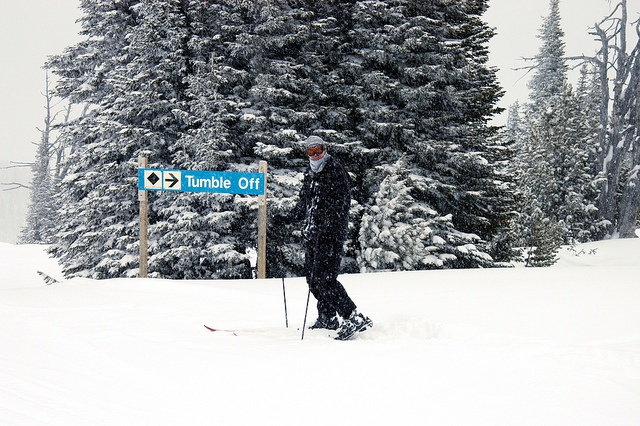Describe the objects in this image and their specific colors. I can see people in lightgray, black, white, gray, and darkgray tones in this image. 